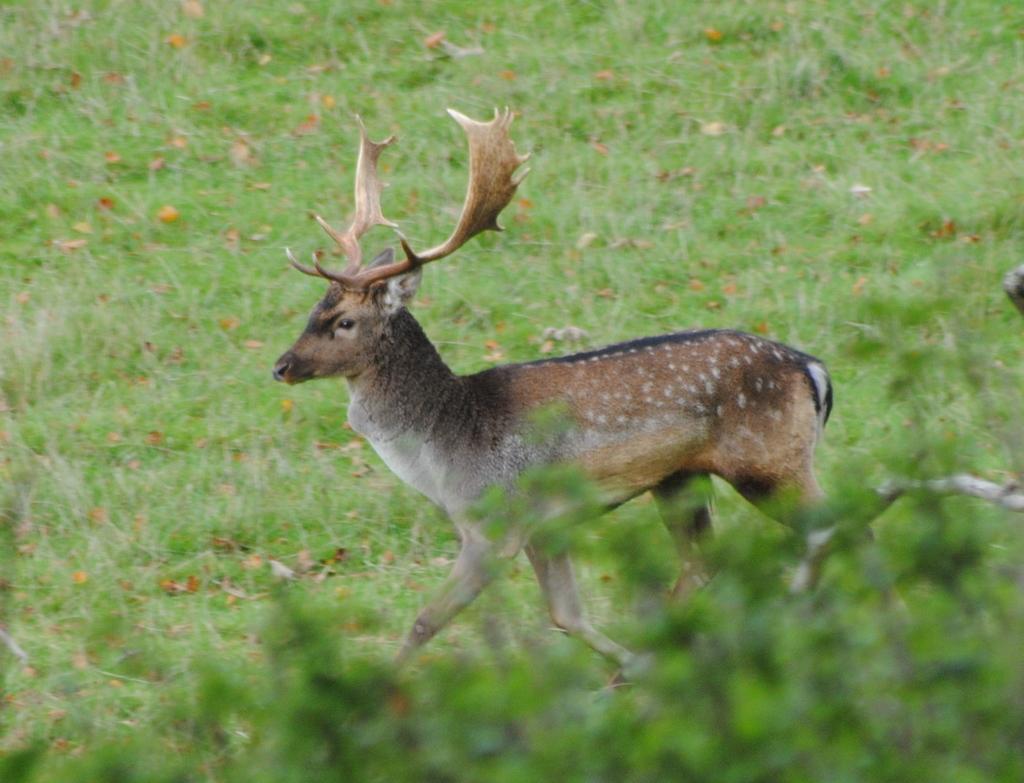Please provide a concise description of this image. In this image there is a dear in a field, in the bottom right there is a plant. 